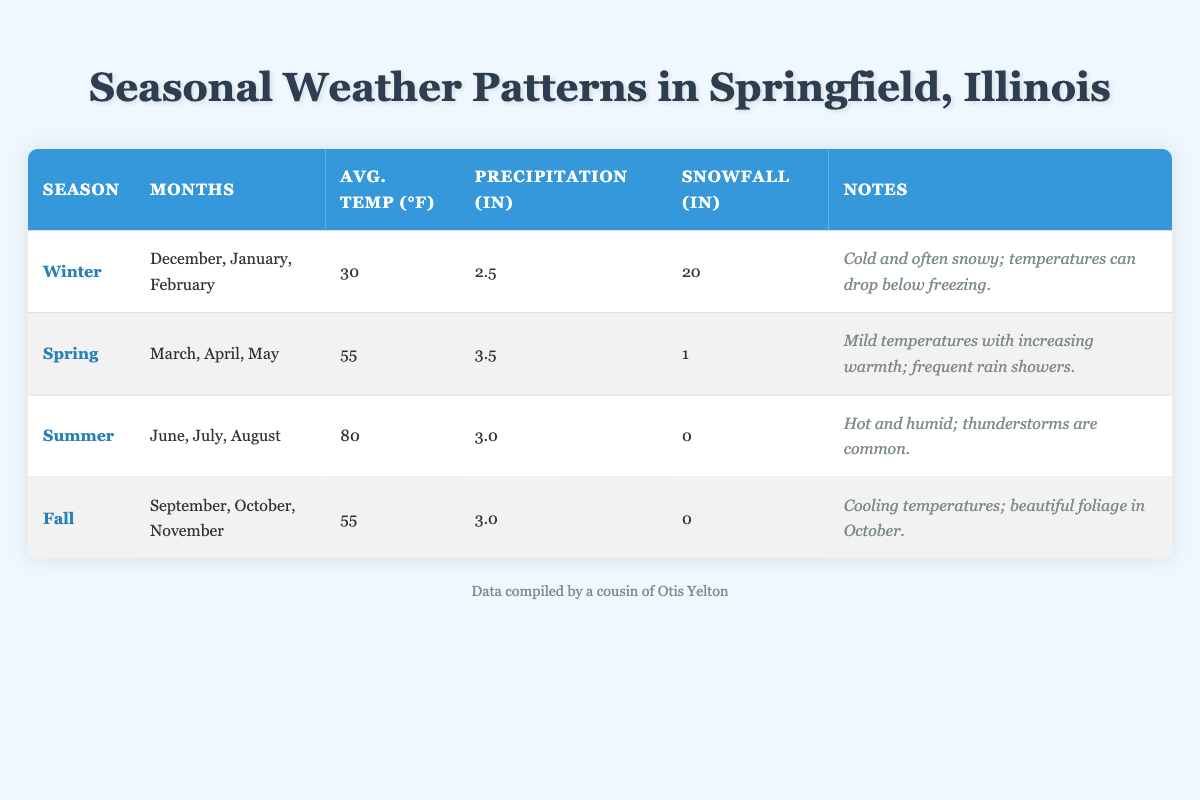What is the average temperature in Winter? The table shows that the average temperature in Winter is listed under the "Avg. Temp (°F)" column for the row labeled "Winter." That value is 30.
Answer: 30°F How much snowfall is recorded on average in Spring? Looking at the row for Spring, the table indicates that the average snowfall in inches is recorded as 1 under the "Snowfall (in)" column.
Answer: 1 inch Which season has the highest average temperature? To determine this, compare the "Avg. Temp (°F)" values across all seasons. The values are 30 for Winter, 55 for Spring, 80 for Summer, and 55 for Fall. The highest value is 80 for Summer.
Answer: Summer What is the total precipitation from Winter and Fall? To calculate this, add the precipitation amounts in inches for Winter (2.5) and Fall (3.0). The sum is 2.5 + 3.0 = 5.5.
Answer: 5.5 inches Does the Summer season have snowfall? The table shows that under the "Snowfall (in)" column for Summer, the value is listed as 0. Therefore, it does not receive any snowfall.
Answer: No What is the average temperature difference between Summer and Spring? The average temperature in Summer is 80°F and in Spring is 55°F. To find the difference, subtract the Spring average from the Summer average: 80 - 55 = 25.
Answer: 25°F During which season does Springfield experience the least average precipitation? Looking through the precipitation values for each season, Winter has 2.5 inches, Spring has 3.5 inches, Summer has 3.0 inches, and Fall has 3.0 inches. The lowest value is 2.5 inches in Winter.
Answer: Winter How many inches of precipitation does Springfield receive on average in the Spring and Summer combined? Adding Spring's precipitation (3.5 inches) and Summer's precipitation (3.0 inches) gives: 3.5 + 3.0 = 6.5 inches combined for both seasons.
Answer: 6.5 inches 